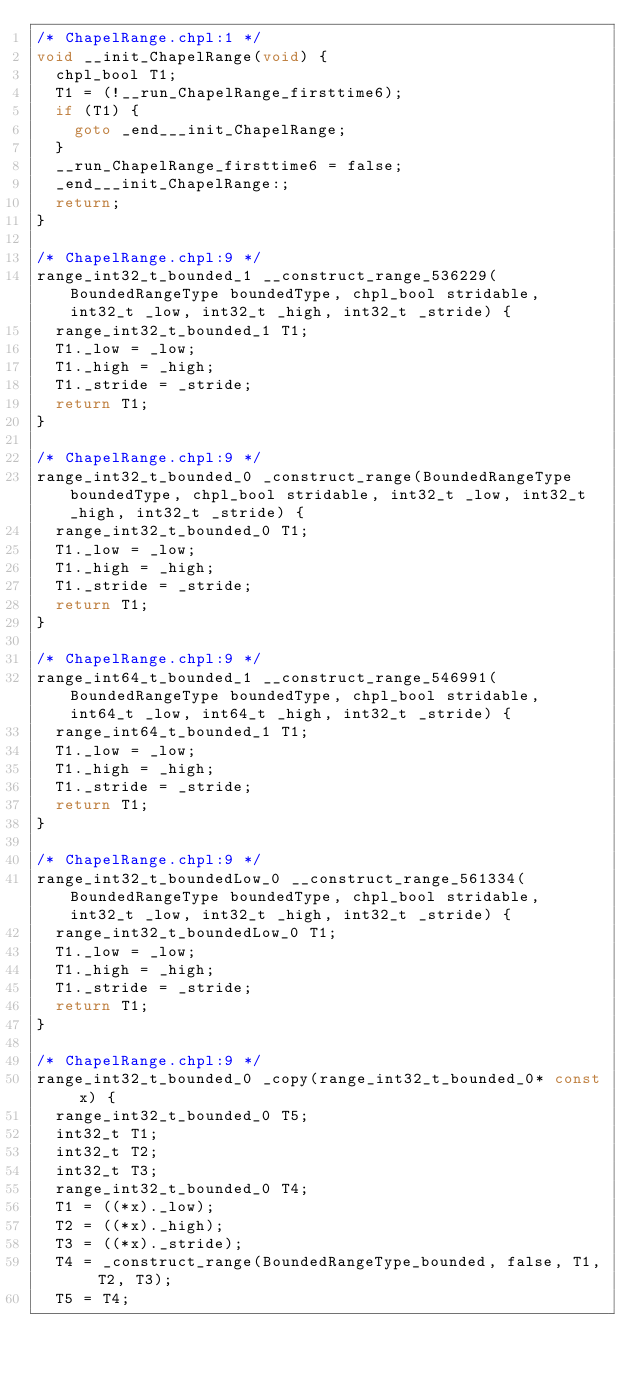Convert code to text. <code><loc_0><loc_0><loc_500><loc_500><_C_>/* ChapelRange.chpl:1 */
void __init_ChapelRange(void) {
  chpl_bool T1;
  T1 = (!__run_ChapelRange_firsttime6);
  if (T1) {
    goto _end___init_ChapelRange;
  }
  __run_ChapelRange_firsttime6 = false;
  _end___init_ChapelRange:;
  return;
}

/* ChapelRange.chpl:9 */
range_int32_t_bounded_1 __construct_range_536229(BoundedRangeType boundedType, chpl_bool stridable, int32_t _low, int32_t _high, int32_t _stride) {
  range_int32_t_bounded_1 T1;
  T1._low = _low;
  T1._high = _high;
  T1._stride = _stride;
  return T1;
}

/* ChapelRange.chpl:9 */
range_int32_t_bounded_0 _construct_range(BoundedRangeType boundedType, chpl_bool stridable, int32_t _low, int32_t _high, int32_t _stride) {
  range_int32_t_bounded_0 T1;
  T1._low = _low;
  T1._high = _high;
  T1._stride = _stride;
  return T1;
}

/* ChapelRange.chpl:9 */
range_int64_t_bounded_1 __construct_range_546991(BoundedRangeType boundedType, chpl_bool stridable, int64_t _low, int64_t _high, int32_t _stride) {
  range_int64_t_bounded_1 T1;
  T1._low = _low;
  T1._high = _high;
  T1._stride = _stride;
  return T1;
}

/* ChapelRange.chpl:9 */
range_int32_t_boundedLow_0 __construct_range_561334(BoundedRangeType boundedType, chpl_bool stridable, int32_t _low, int32_t _high, int32_t _stride) {
  range_int32_t_boundedLow_0 T1;
  T1._low = _low;
  T1._high = _high;
  T1._stride = _stride;
  return T1;
}

/* ChapelRange.chpl:9 */
range_int32_t_bounded_0 _copy(range_int32_t_bounded_0* const x) {
  range_int32_t_bounded_0 T5;
  int32_t T1;
  int32_t T2;
  int32_t T3;
  range_int32_t_bounded_0 T4;
  T1 = ((*x)._low);
  T2 = ((*x)._high);
  T3 = ((*x)._stride);
  T4 = _construct_range(BoundedRangeType_bounded, false, T1, T2, T3);
  T5 = T4;</code> 